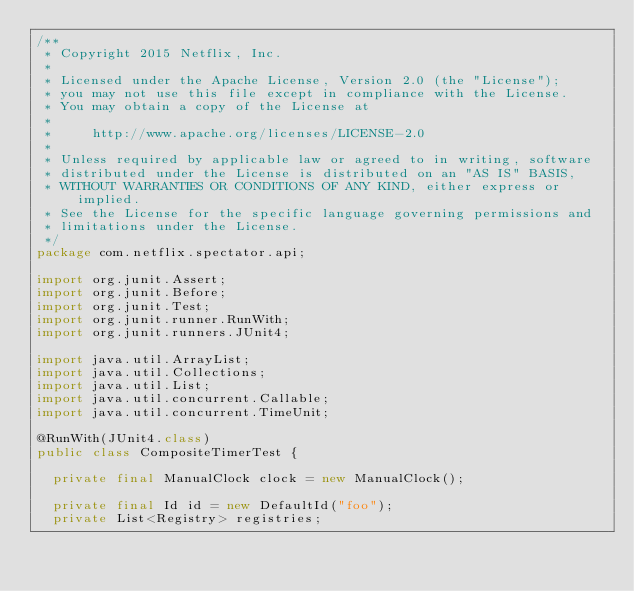<code> <loc_0><loc_0><loc_500><loc_500><_Java_>/**
 * Copyright 2015 Netflix, Inc.
 *
 * Licensed under the Apache License, Version 2.0 (the "License");
 * you may not use this file except in compliance with the License.
 * You may obtain a copy of the License at
 *
 *     http://www.apache.org/licenses/LICENSE-2.0
 *
 * Unless required by applicable law or agreed to in writing, software
 * distributed under the License is distributed on an "AS IS" BASIS,
 * WITHOUT WARRANTIES OR CONDITIONS OF ANY KIND, either express or implied.
 * See the License for the specific language governing permissions and
 * limitations under the License.
 */
package com.netflix.spectator.api;

import org.junit.Assert;
import org.junit.Before;
import org.junit.Test;
import org.junit.runner.RunWith;
import org.junit.runners.JUnit4;

import java.util.ArrayList;
import java.util.Collections;
import java.util.List;
import java.util.concurrent.Callable;
import java.util.concurrent.TimeUnit;

@RunWith(JUnit4.class)
public class CompositeTimerTest {

  private final ManualClock clock = new ManualClock();

  private final Id id = new DefaultId("foo");
  private List<Registry> registries;
</code> 